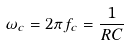Convert formula to latex. <formula><loc_0><loc_0><loc_500><loc_500>\omega _ { c } = 2 \pi f _ { c } = \frac { 1 } { R C }</formula> 